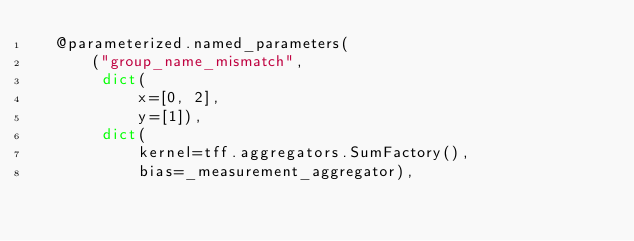Convert code to text. <code><loc_0><loc_0><loc_500><loc_500><_Python_>  @parameterized.named_parameters(
      ("group_name_mismatch",
       dict(
           x=[0, 2],
           y=[1]),
       dict(
           kernel=tff.aggregators.SumFactory(),
           bias=_measurement_aggregator),</code> 